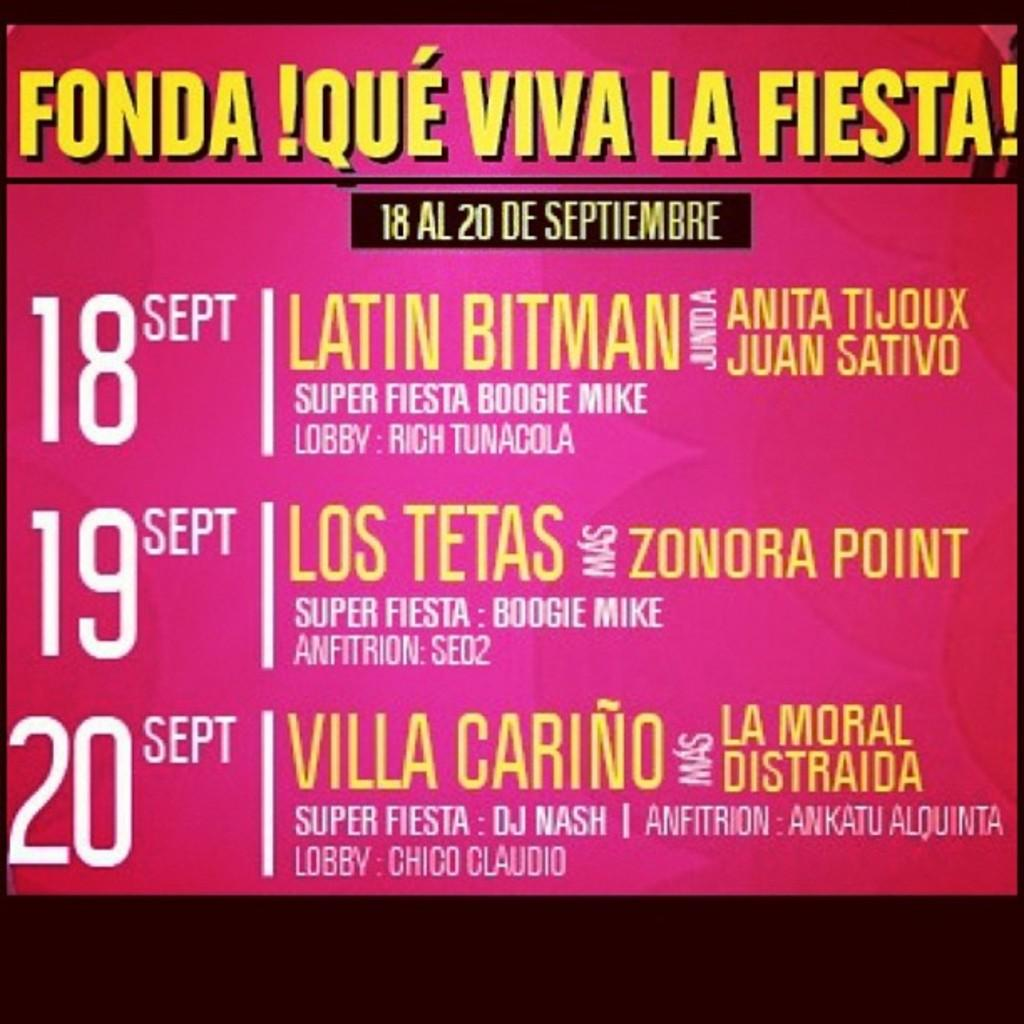<image>
Create a compact narrative representing the image presented. A billboard advertising dates for shows like Latin Bitman, Los Tetas and Villa Carino. 